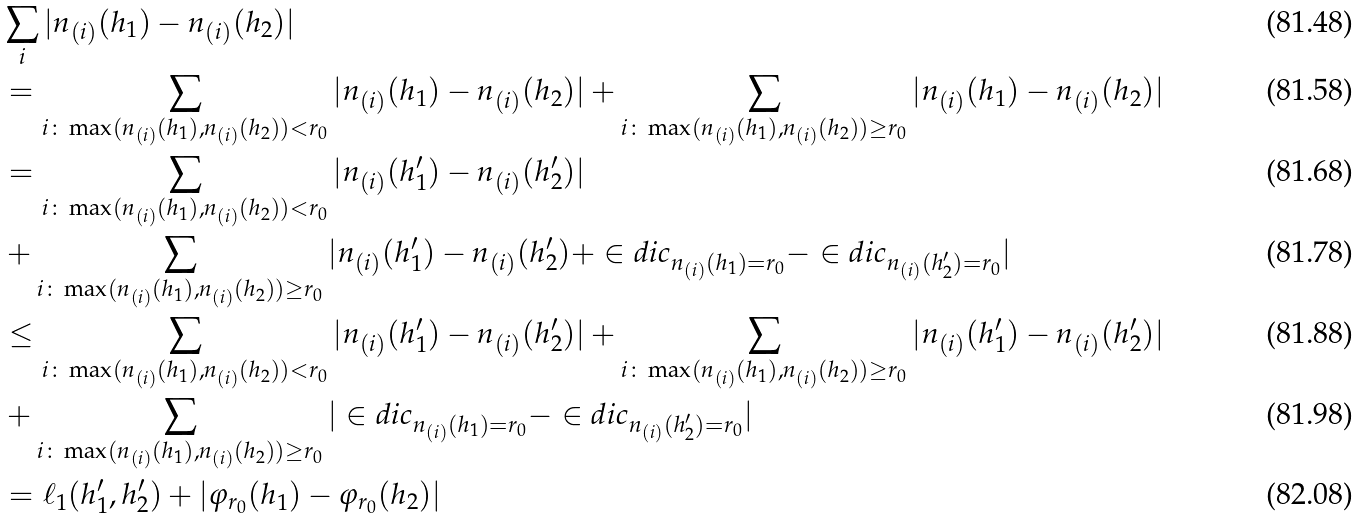<formula> <loc_0><loc_0><loc_500><loc_500>& \sum _ { i } | n _ { ( i ) } ( h _ { 1 } ) - n _ { ( i ) } ( h _ { 2 } ) | \\ & = \sum _ { i \colon \max ( n _ { ( i ) } ( h _ { 1 } ) , n _ { ( i ) } ( h _ { 2 } ) ) < r _ { 0 } } | n _ { ( i ) } ( h _ { 1 } ) - n _ { ( i ) } ( h _ { 2 } ) | + \sum _ { i \colon \max ( n _ { ( i ) } ( h _ { 1 } ) , n _ { ( i ) } ( h _ { 2 } ) ) \geq r _ { 0 } } | n _ { ( i ) } ( h _ { 1 } ) - n _ { ( i ) } ( h _ { 2 } ) | \\ & = \sum _ { i \colon \max ( n _ { ( i ) } ( h _ { 1 } ) , n _ { ( i ) } ( h _ { 2 } ) ) < r _ { 0 } } | n _ { ( i ) } ( h ^ { \prime } _ { 1 } ) - n _ { ( i ) } ( h ^ { \prime } _ { 2 } ) | \\ & + \sum _ { i \colon \max ( n _ { ( i ) } ( h _ { 1 } ) , n _ { ( i ) } ( h _ { 2 } ) ) \geq r _ { 0 } } | n _ { ( i ) } ( h ^ { \prime } _ { 1 } ) - n _ { ( i ) } ( h ^ { \prime } _ { 2 } ) + \in d i c _ { n _ { ( i ) } ( h _ { 1 } ) = r _ { 0 } } - \in d i c _ { n _ { ( i ) } ( h ^ { \prime } _ { 2 } ) = r _ { 0 } } | \\ & \leq \sum _ { i \colon \max ( n _ { ( i ) } ( h _ { 1 } ) , n _ { ( i ) } ( h _ { 2 } ) ) < r _ { 0 } } | n _ { ( i ) } ( h ^ { \prime } _ { 1 } ) - n _ { ( i ) } ( h ^ { \prime } _ { 2 } ) | + \sum _ { i \colon \max ( n _ { ( i ) } ( h _ { 1 } ) , n _ { ( i ) } ( h _ { 2 } ) ) \geq r _ { 0 } } | n _ { ( i ) } ( h ^ { \prime } _ { 1 } ) - n _ { ( i ) } ( h ^ { \prime } _ { 2 } ) | \\ & + \sum _ { i \colon \max ( n _ { ( i ) } ( h _ { 1 } ) , n _ { ( i ) } ( h _ { 2 } ) ) \geq r _ { 0 } } | \in d i c _ { n _ { ( i ) } ( h _ { 1 } ) = r _ { 0 } } - \in d i c _ { n _ { ( i ) } ( h ^ { \prime } _ { 2 } ) = r _ { 0 } } | \\ & = \ell _ { 1 } ( h ^ { \prime } _ { 1 } , h ^ { \prime } _ { 2 } ) + | \varphi _ { r _ { 0 } } ( h _ { 1 } ) - \varphi _ { r _ { 0 } } ( h _ { 2 } ) |</formula> 